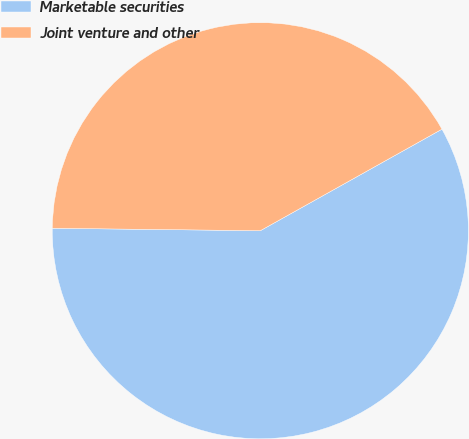<chart> <loc_0><loc_0><loc_500><loc_500><pie_chart><fcel>Marketable securities<fcel>Joint venture and other<nl><fcel>58.3%<fcel>41.7%<nl></chart> 